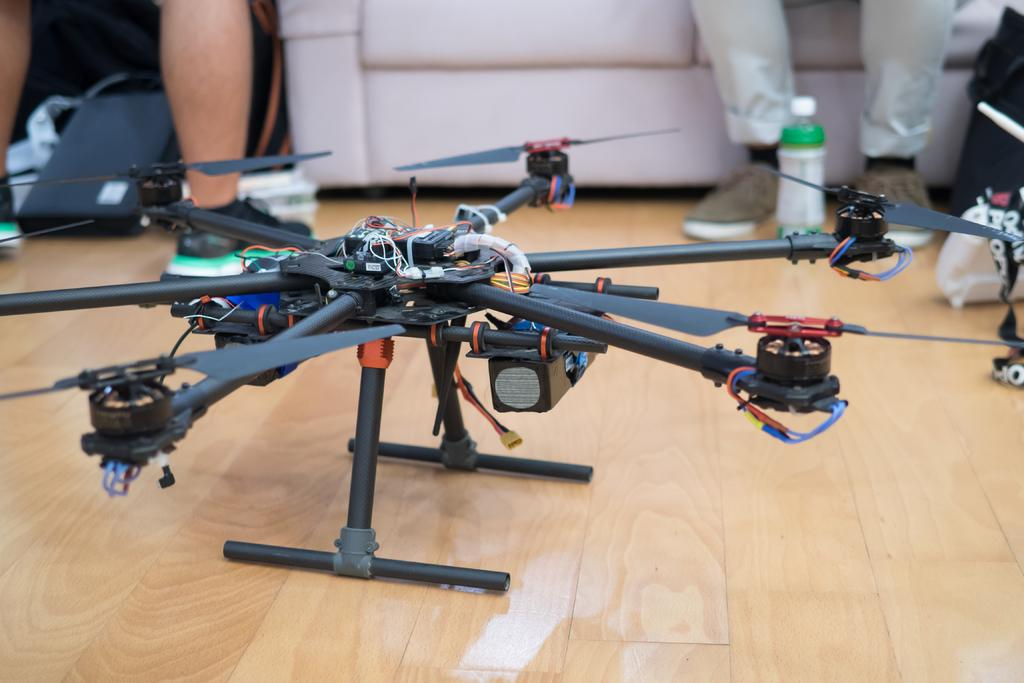What is on the floor in the image? There is a gadget on the floor in the image. What else can be seen around the gadget? There are other things around the gadget. Can you describe the presence of people in the image? The legs of two people are visible in the image. What color are the eyes of the person wearing a skirt in the image? There is no person wearing a skirt in the image, and no eyes are visible. 